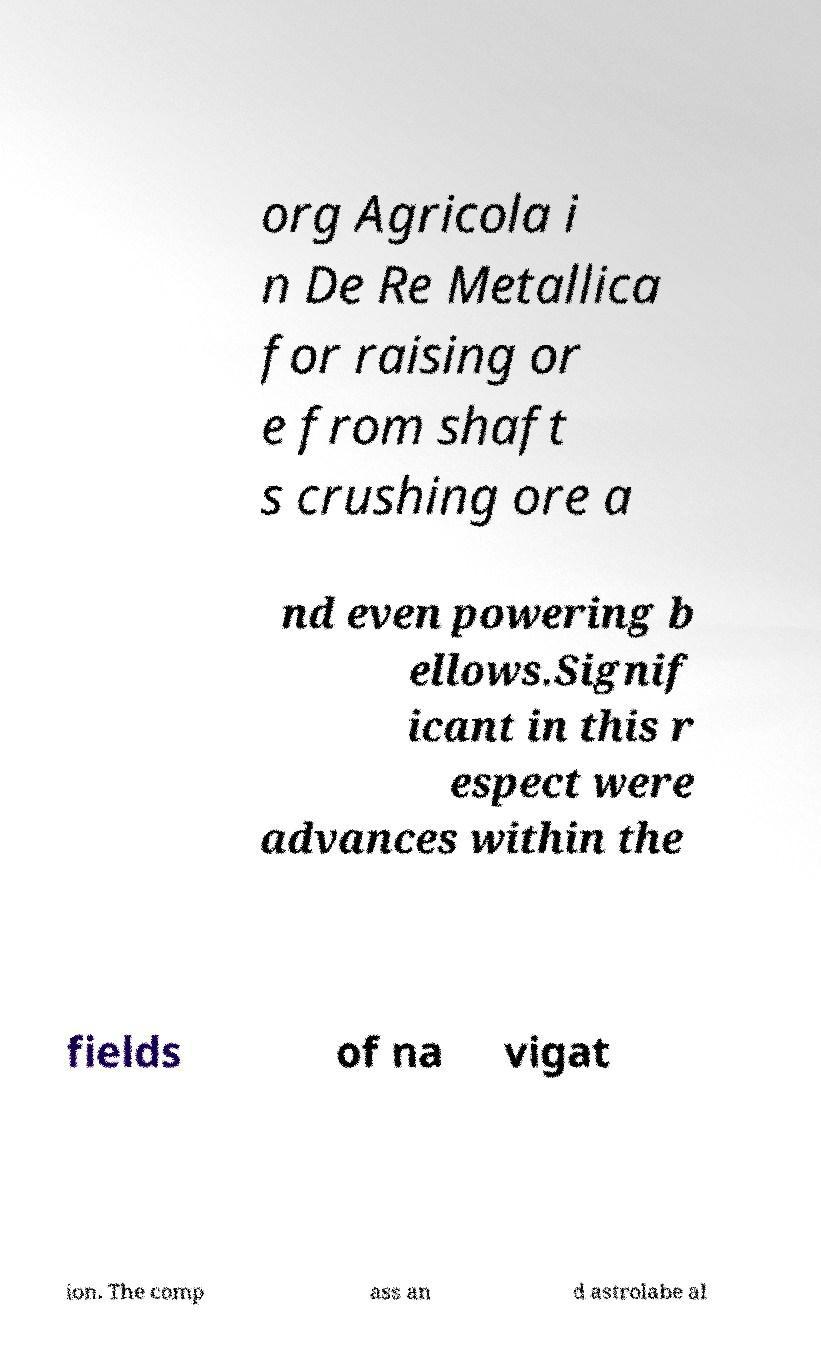Can you accurately transcribe the text from the provided image for me? org Agricola i n De Re Metallica for raising or e from shaft s crushing ore a nd even powering b ellows.Signif icant in this r espect were advances within the fields of na vigat ion. The comp ass an d astrolabe al 